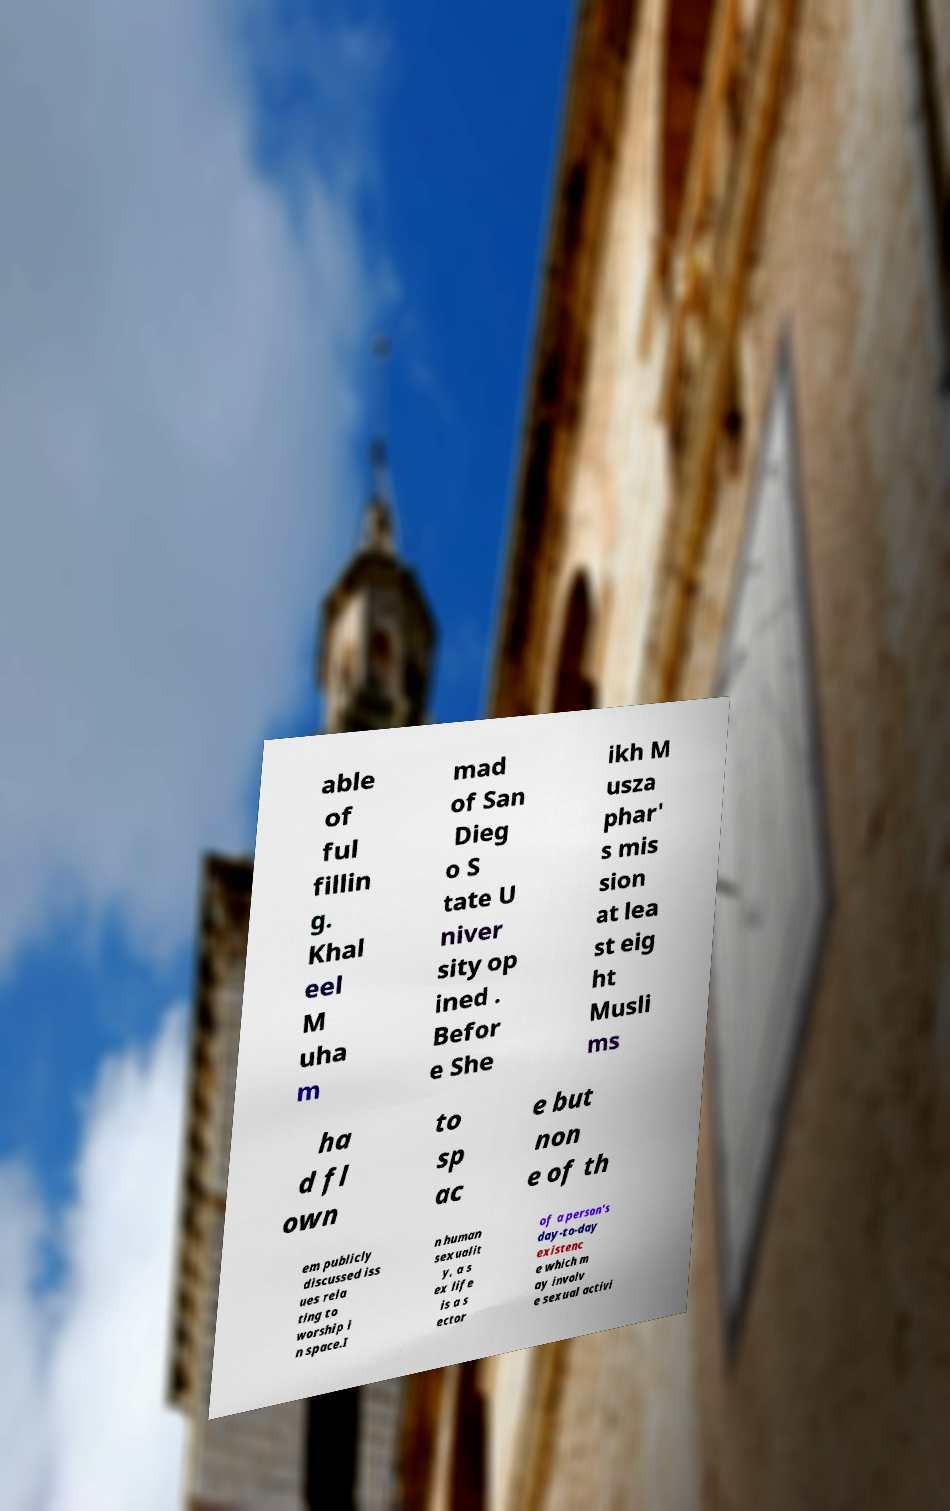I need the written content from this picture converted into text. Can you do that? able of ful fillin g. Khal eel M uha m mad of San Dieg o S tate U niver sity op ined . Befor e She ikh M usza phar' s mis sion at lea st eig ht Musli ms ha d fl own to sp ac e but non e of th em publicly discussed iss ues rela ting to worship i n space.I n human sexualit y, a s ex life is a s ector of a person's day-to-day existenc e which m ay involv e sexual activi 